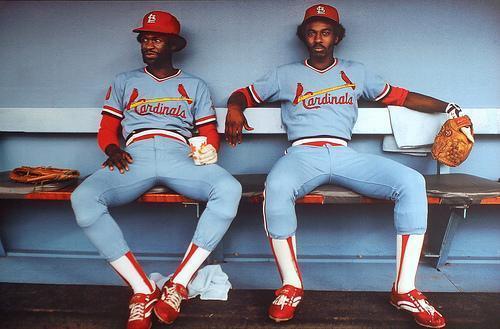How many men are there?
Give a very brief answer. 2. 